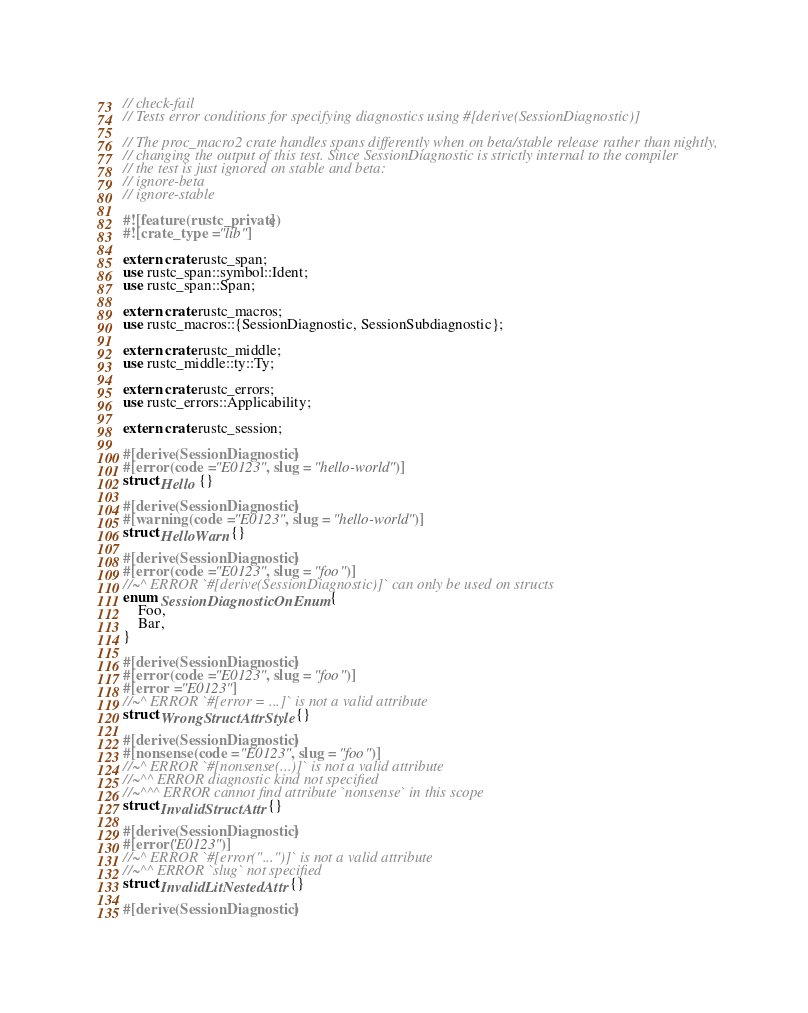<code> <loc_0><loc_0><loc_500><loc_500><_Rust_>// check-fail
// Tests error conditions for specifying diagnostics using #[derive(SessionDiagnostic)]

// The proc_macro2 crate handles spans differently when on beta/stable release rather than nightly,
// changing the output of this test. Since SessionDiagnostic is strictly internal to the compiler
// the test is just ignored on stable and beta:
// ignore-beta
// ignore-stable

#![feature(rustc_private)]
#![crate_type = "lib"]

extern crate rustc_span;
use rustc_span::symbol::Ident;
use rustc_span::Span;

extern crate rustc_macros;
use rustc_macros::{SessionDiagnostic, SessionSubdiagnostic};

extern crate rustc_middle;
use rustc_middle::ty::Ty;

extern crate rustc_errors;
use rustc_errors::Applicability;

extern crate rustc_session;

#[derive(SessionDiagnostic)]
#[error(code = "E0123", slug = "hello-world")]
struct Hello {}

#[derive(SessionDiagnostic)]
#[warning(code = "E0123", slug = "hello-world")]
struct HelloWarn {}

#[derive(SessionDiagnostic)]
#[error(code = "E0123", slug = "foo")]
//~^ ERROR `#[derive(SessionDiagnostic)]` can only be used on structs
enum SessionDiagnosticOnEnum {
    Foo,
    Bar,
}

#[derive(SessionDiagnostic)]
#[error(code = "E0123", slug = "foo")]
#[error = "E0123"]
//~^ ERROR `#[error = ...]` is not a valid attribute
struct WrongStructAttrStyle {}

#[derive(SessionDiagnostic)]
#[nonsense(code = "E0123", slug = "foo")]
//~^ ERROR `#[nonsense(...)]` is not a valid attribute
//~^^ ERROR diagnostic kind not specified
//~^^^ ERROR cannot find attribute `nonsense` in this scope
struct InvalidStructAttr {}

#[derive(SessionDiagnostic)]
#[error("E0123")]
//~^ ERROR `#[error("...")]` is not a valid attribute
//~^^ ERROR `slug` not specified
struct InvalidLitNestedAttr {}

#[derive(SessionDiagnostic)]</code> 